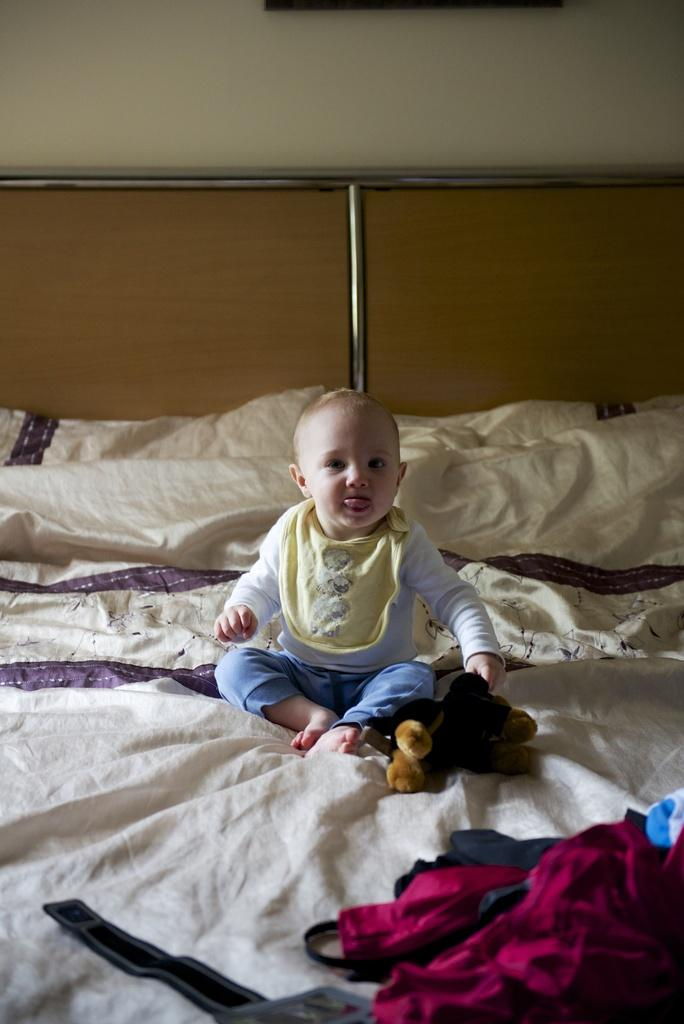What is the main subject of the image? There is a baby in the image. Where is the baby located? The baby is sitting on a bed. What else can be seen in the image besides the baby? There are clothes visible in the image. How many apples are being used as a rest for the baby in the image? There are no apples present in the image, and the baby is not using any objects as a rest. 